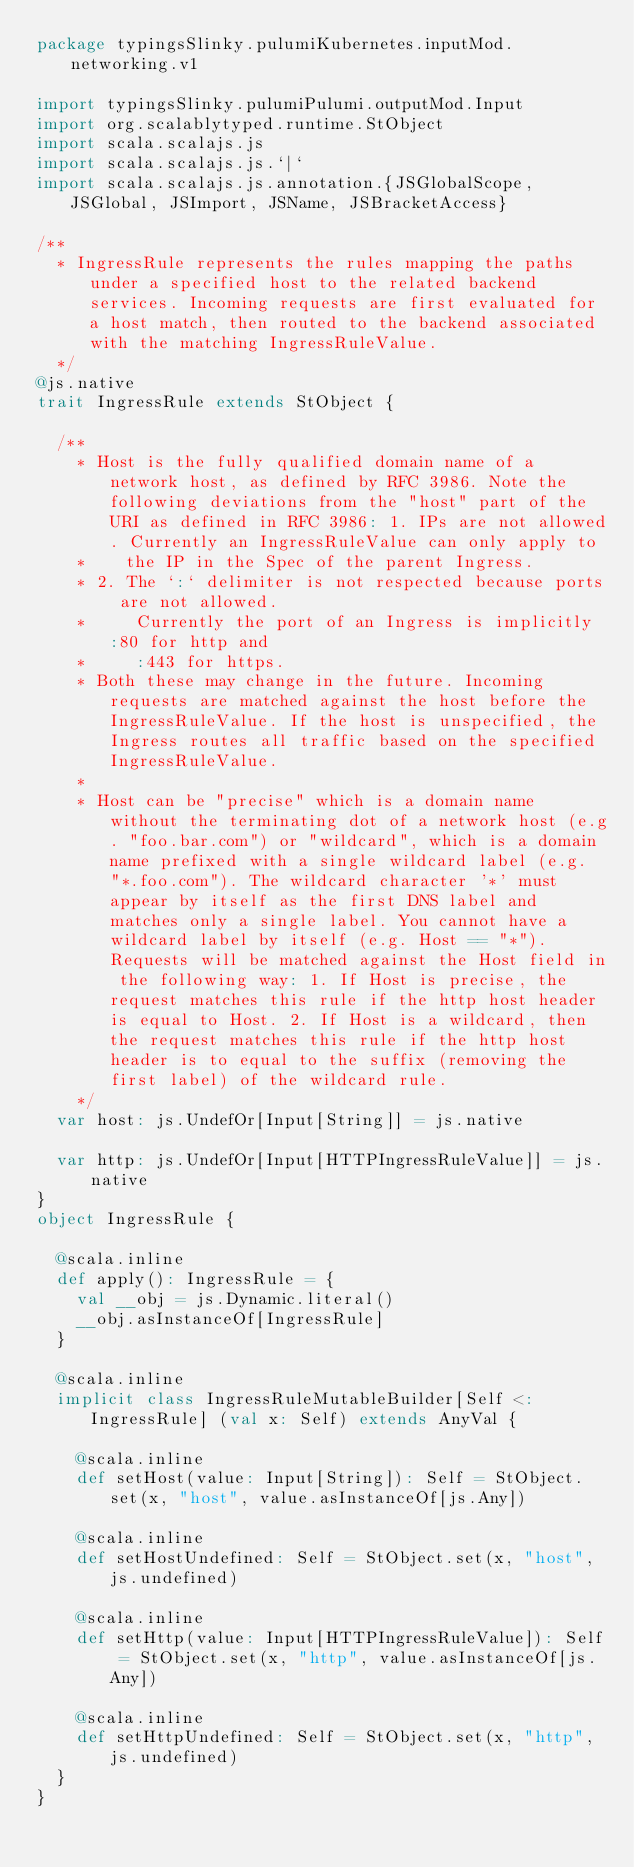Convert code to text. <code><loc_0><loc_0><loc_500><loc_500><_Scala_>package typingsSlinky.pulumiKubernetes.inputMod.networking.v1

import typingsSlinky.pulumiPulumi.outputMod.Input
import org.scalablytyped.runtime.StObject
import scala.scalajs.js
import scala.scalajs.js.`|`
import scala.scalajs.js.annotation.{JSGlobalScope, JSGlobal, JSImport, JSName, JSBracketAccess}

/**
  * IngressRule represents the rules mapping the paths under a specified host to the related backend services. Incoming requests are first evaluated for a host match, then routed to the backend associated with the matching IngressRuleValue.
  */
@js.native
trait IngressRule extends StObject {
  
  /**
    * Host is the fully qualified domain name of a network host, as defined by RFC 3986. Note the following deviations from the "host" part of the URI as defined in RFC 3986: 1. IPs are not allowed. Currently an IngressRuleValue can only apply to
    *    the IP in the Spec of the parent Ingress.
    * 2. The `:` delimiter is not respected because ports are not allowed.
    * 	  Currently the port of an Ingress is implicitly :80 for http and
    * 	  :443 for https.
    * Both these may change in the future. Incoming requests are matched against the host before the IngressRuleValue. If the host is unspecified, the Ingress routes all traffic based on the specified IngressRuleValue.
    *
    * Host can be "precise" which is a domain name without the terminating dot of a network host (e.g. "foo.bar.com") or "wildcard", which is a domain name prefixed with a single wildcard label (e.g. "*.foo.com"). The wildcard character '*' must appear by itself as the first DNS label and matches only a single label. You cannot have a wildcard label by itself (e.g. Host == "*"). Requests will be matched against the Host field in the following way: 1. If Host is precise, the request matches this rule if the http host header is equal to Host. 2. If Host is a wildcard, then the request matches this rule if the http host header is to equal to the suffix (removing the first label) of the wildcard rule.
    */
  var host: js.UndefOr[Input[String]] = js.native
  
  var http: js.UndefOr[Input[HTTPIngressRuleValue]] = js.native
}
object IngressRule {
  
  @scala.inline
  def apply(): IngressRule = {
    val __obj = js.Dynamic.literal()
    __obj.asInstanceOf[IngressRule]
  }
  
  @scala.inline
  implicit class IngressRuleMutableBuilder[Self <: IngressRule] (val x: Self) extends AnyVal {
    
    @scala.inline
    def setHost(value: Input[String]): Self = StObject.set(x, "host", value.asInstanceOf[js.Any])
    
    @scala.inline
    def setHostUndefined: Self = StObject.set(x, "host", js.undefined)
    
    @scala.inline
    def setHttp(value: Input[HTTPIngressRuleValue]): Self = StObject.set(x, "http", value.asInstanceOf[js.Any])
    
    @scala.inline
    def setHttpUndefined: Self = StObject.set(x, "http", js.undefined)
  }
}
</code> 